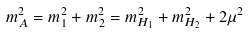Convert formula to latex. <formula><loc_0><loc_0><loc_500><loc_500>m _ { A } ^ { 2 } = m _ { 1 } ^ { 2 } + m _ { 2 } ^ { 2 } = m _ { H _ { 1 } } ^ { 2 } + m _ { H _ { 2 } } ^ { 2 } + 2 \mu ^ { 2 }</formula> 